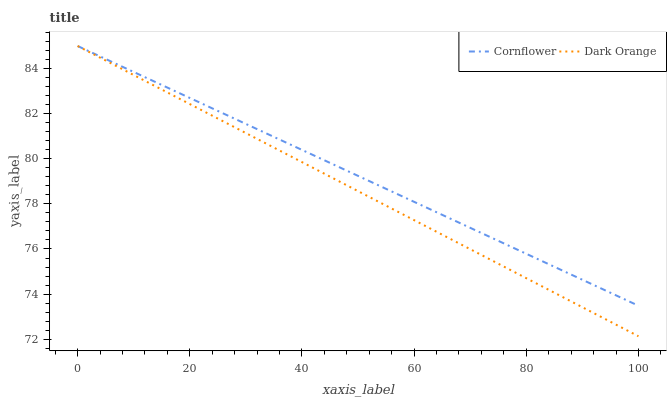Does Dark Orange have the minimum area under the curve?
Answer yes or no. Yes. Does Cornflower have the maximum area under the curve?
Answer yes or no. Yes. Does Dark Orange have the maximum area under the curve?
Answer yes or no. No. Is Dark Orange the smoothest?
Answer yes or no. Yes. Is Cornflower the roughest?
Answer yes or no. Yes. Is Dark Orange the roughest?
Answer yes or no. No. Does Dark Orange have the lowest value?
Answer yes or no. Yes. Does Dark Orange have the highest value?
Answer yes or no. Yes. Does Cornflower intersect Dark Orange?
Answer yes or no. Yes. Is Cornflower less than Dark Orange?
Answer yes or no. No. Is Cornflower greater than Dark Orange?
Answer yes or no. No. 